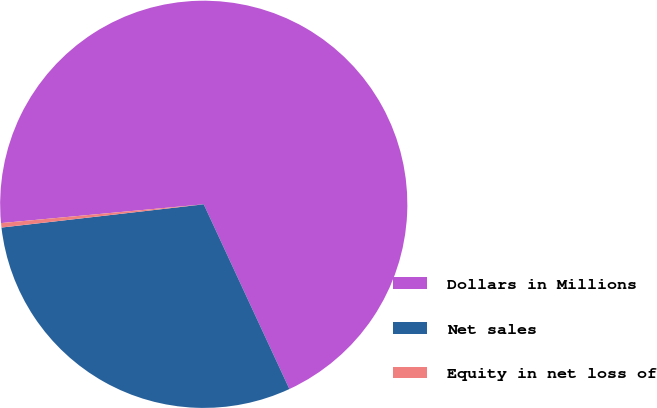Convert chart to OTSL. <chart><loc_0><loc_0><loc_500><loc_500><pie_chart><fcel>Dollars in Millions<fcel>Net sales<fcel>Equity in net loss of<nl><fcel>69.56%<fcel>30.09%<fcel>0.35%<nl></chart> 